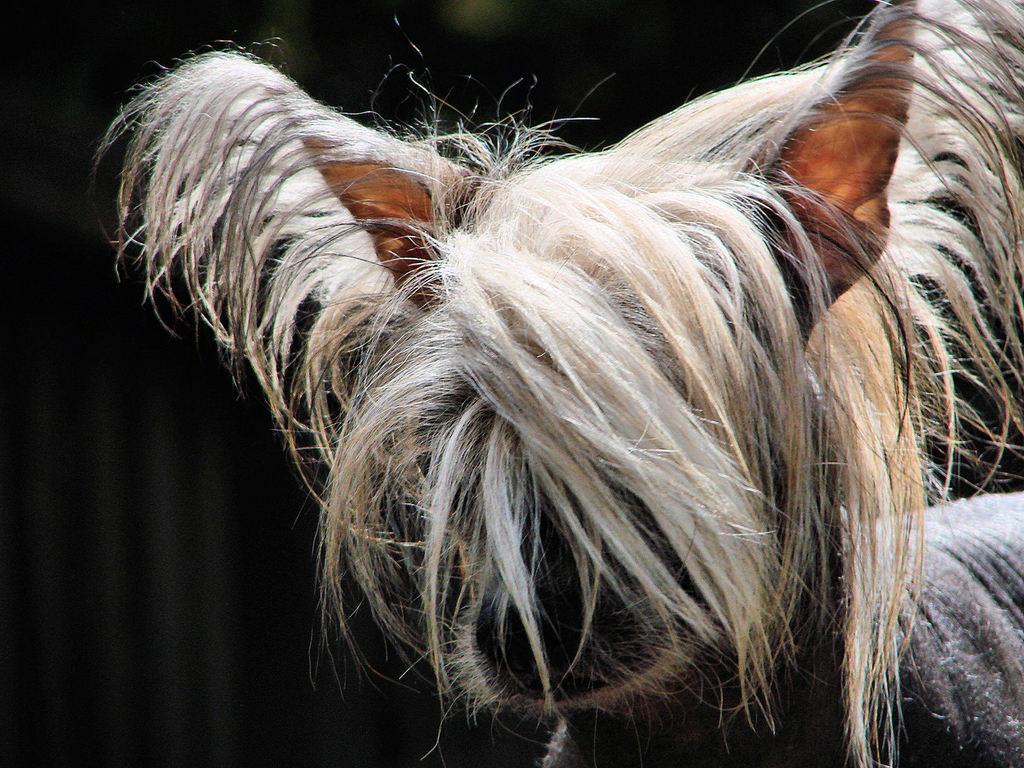How would you summarize this image in a sentence or two? In the picture I can see an animal. The background of the image is dark. 